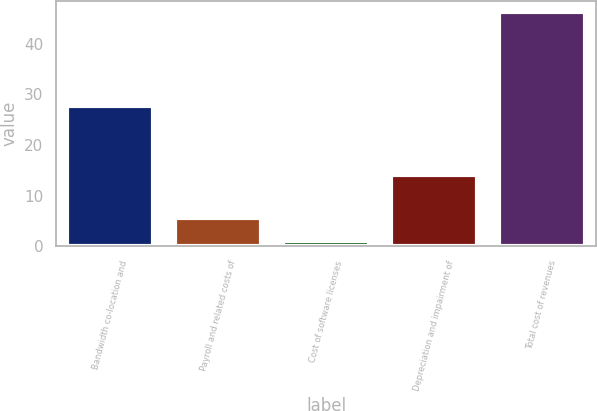Convert chart to OTSL. <chart><loc_0><loc_0><loc_500><loc_500><bar_chart><fcel>Bandwidth co-location and<fcel>Payroll and related costs of<fcel>Cost of software licenses<fcel>Depreciation and impairment of<fcel>Total cost of revenues<nl><fcel>27.7<fcel>5.52<fcel>1<fcel>14<fcel>46.2<nl></chart> 